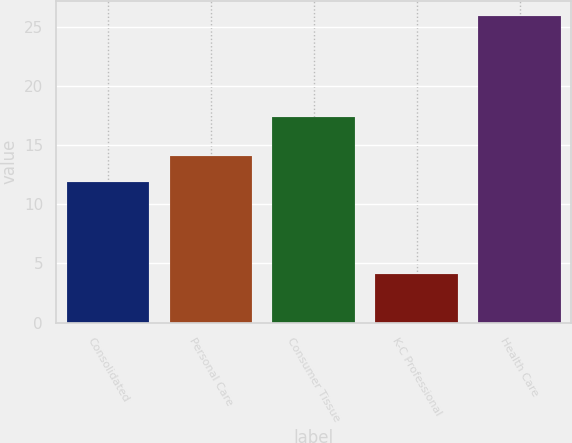<chart> <loc_0><loc_0><loc_500><loc_500><bar_chart><fcel>Consolidated<fcel>Personal Care<fcel>Consumer Tissue<fcel>K-C Professional<fcel>Health Care<nl><fcel>11.9<fcel>14.08<fcel>17.4<fcel>4.1<fcel>25.9<nl></chart> 